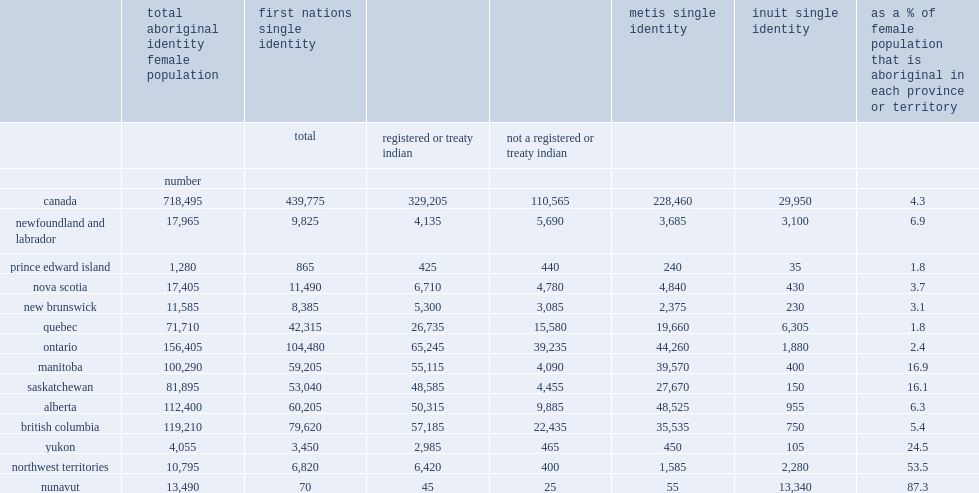In manitoba, how many percent of the total female population was comprised of aboriginal females? 16.9. In saskatchewan, how many percent of the total female population was comprised of aboriginal females? 16.1. In nunavut, what was the percent of females reported an aboriginal identity? 87.3. In the northwest territories, what was the percent of females reported an aboriginal identity? 53.5. In the yukon, what was the percent of females reported an aboriginal identity? 24.5. 